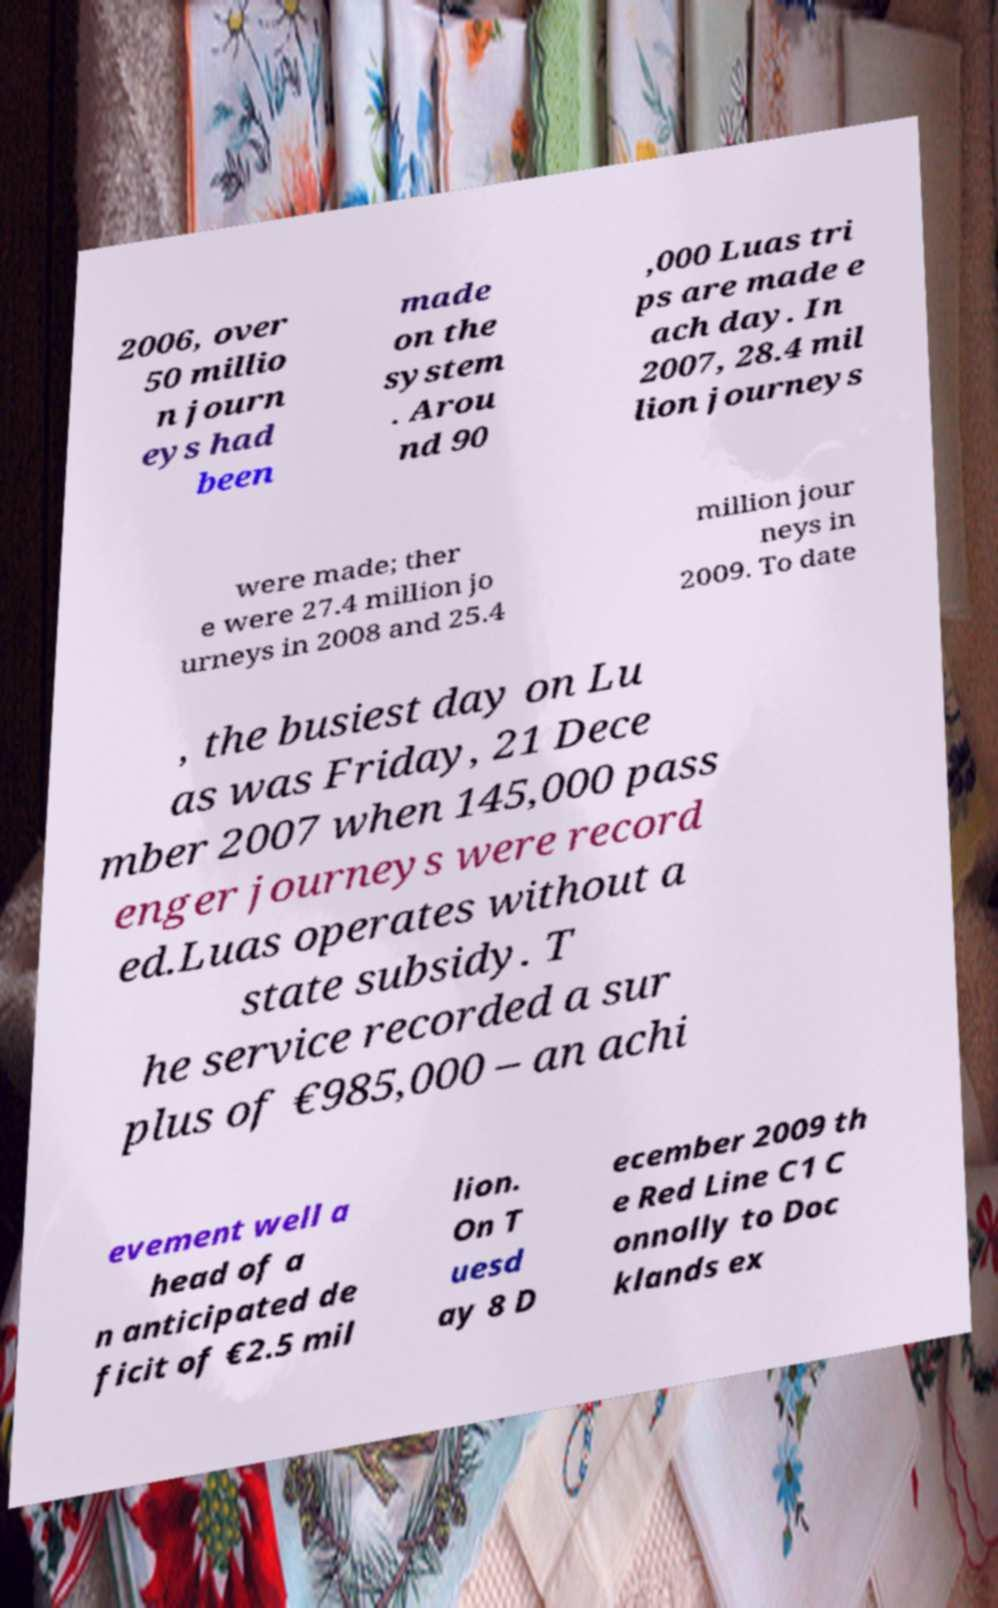Could you extract and type out the text from this image? 2006, over 50 millio n journ eys had been made on the system . Arou nd 90 ,000 Luas tri ps are made e ach day. In 2007, 28.4 mil lion journeys were made; ther e were 27.4 million jo urneys in 2008 and 25.4 million jour neys in 2009. To date , the busiest day on Lu as was Friday, 21 Dece mber 2007 when 145,000 pass enger journeys were record ed.Luas operates without a state subsidy. T he service recorded a sur plus of €985,000 – an achi evement well a head of a n anticipated de ficit of €2.5 mil lion. On T uesd ay 8 D ecember 2009 th e Red Line C1 C onnolly to Doc klands ex 